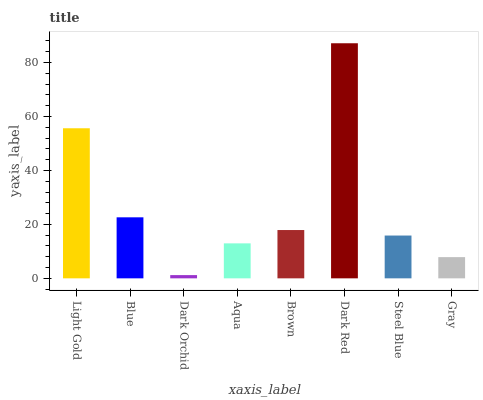Is Dark Orchid the minimum?
Answer yes or no. Yes. Is Dark Red the maximum?
Answer yes or no. Yes. Is Blue the minimum?
Answer yes or no. No. Is Blue the maximum?
Answer yes or no. No. Is Light Gold greater than Blue?
Answer yes or no. Yes. Is Blue less than Light Gold?
Answer yes or no. Yes. Is Blue greater than Light Gold?
Answer yes or no. No. Is Light Gold less than Blue?
Answer yes or no. No. Is Brown the high median?
Answer yes or no. Yes. Is Steel Blue the low median?
Answer yes or no. Yes. Is Light Gold the high median?
Answer yes or no. No. Is Dark Orchid the low median?
Answer yes or no. No. 